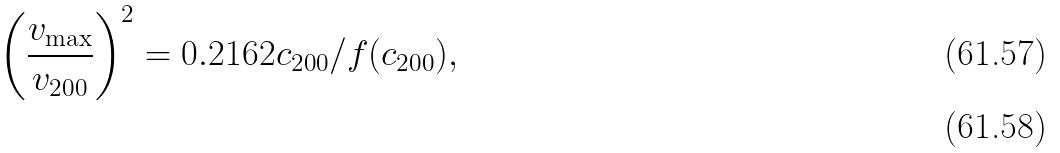Convert formula to latex. <formula><loc_0><loc_0><loc_500><loc_500>\left ( \frac { v _ { \max } } { v _ { 2 0 0 } } \right ) ^ { 2 } = 0 . 2 1 6 2 c _ { 2 0 0 } / f ( c _ { 2 0 0 } ) , \\</formula> 